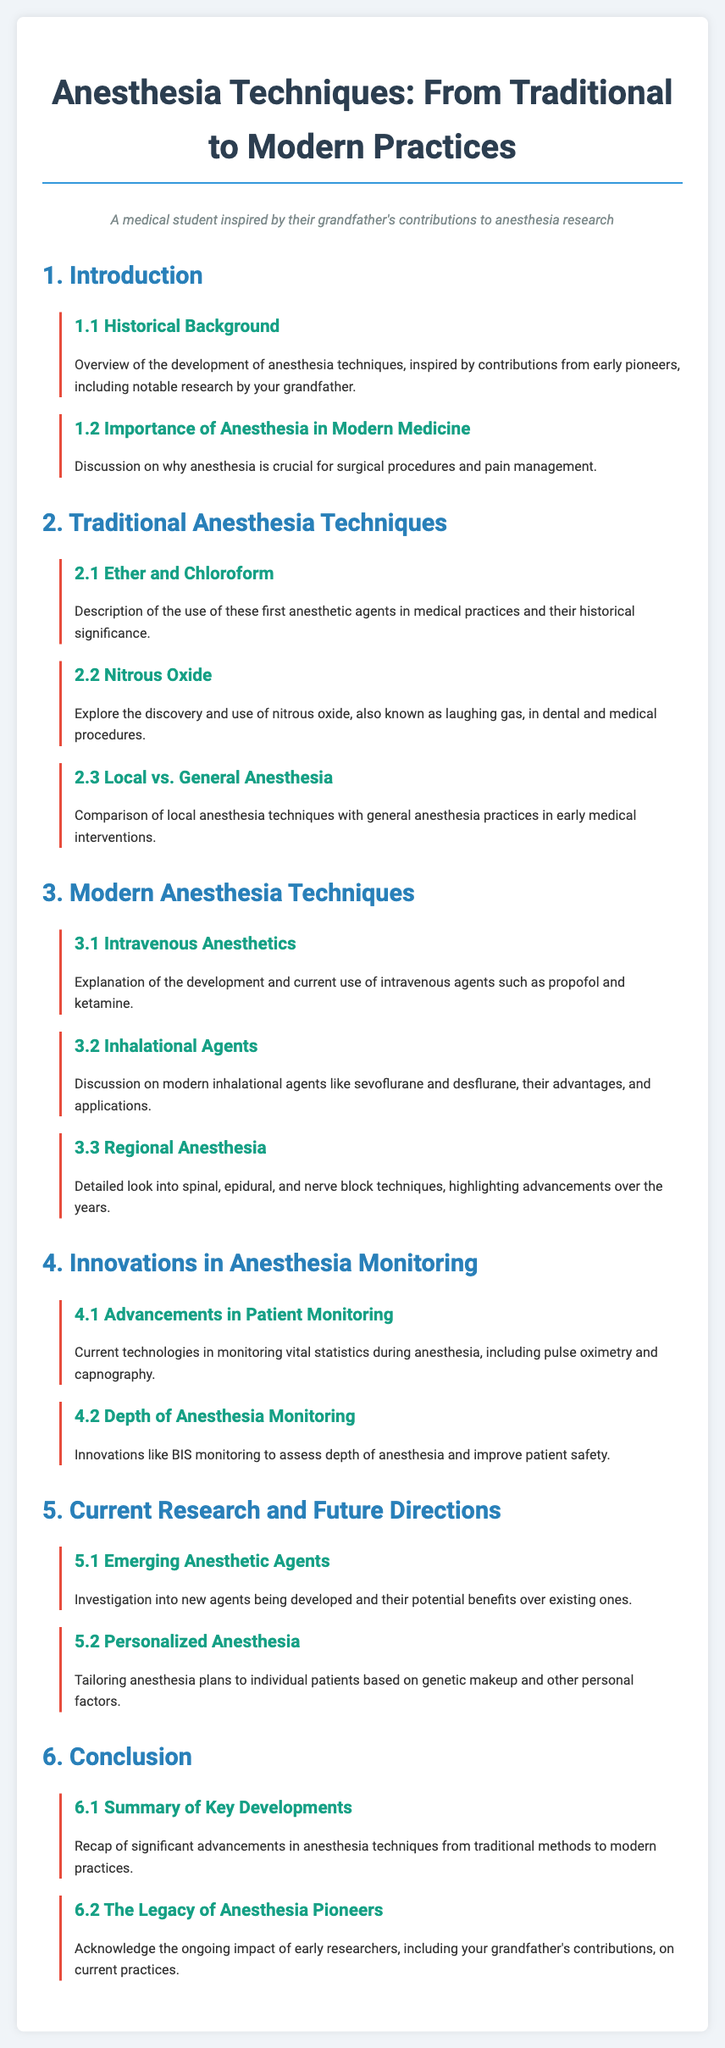What is the title of the document? The title is the main heading of the document, which introduces the overall topic covered.
Answer: Anesthesia Techniques: From Traditional to Modern Practices What section discusses historical background? The section number provides a way to locate specific topics, and the subsection offers details about the history of anesthesia.
Answer: 1.1 Historical Background Which agent is mentioned as known as laughing gas? The subsection specifically names the agent in its description and highlights its common usage in procedures.
Answer: Nitrous Oxide What is one modern inhalational agent? The document lists specific agents under modern practices, making it clear which are currently used.
Answer: Sevoflurane What is the focus of section 5? The section provides the overall theme relating to the advancements and future trends in anesthesia.
Answer: Current Research and Future Directions What technique is detailed in section 3.3? This subsection describes a specific anesthesia approach that has seen advancements over time.
Answer: Regional Anesthesia Which monitoring technology is mentioned in section 4.1? The monitoring aspect provides insight into current practices in ensuring patient safety during anesthesia.
Answer: Pulse oximetry What is emphasized in section 6.2? This section highlights the significance of early researchers and their impact on current practices in anesthesia.
Answer: The Legacy of Anesthesia Pioneers 